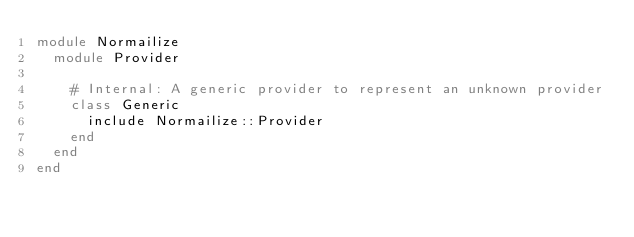<code> <loc_0><loc_0><loc_500><loc_500><_Ruby_>module Normailize
  module Provider

    # Internal: A generic provider to represent an unknown provider
    class Generic
      include Normailize::Provider
    end
  end
end
</code> 